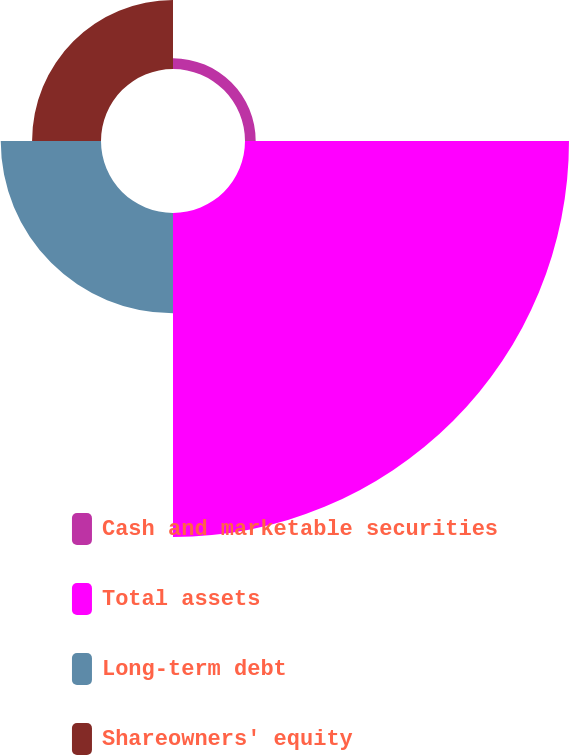Convert chart to OTSL. <chart><loc_0><loc_0><loc_500><loc_500><pie_chart><fcel>Cash and marketable securities<fcel>Total assets<fcel>Long-term debt<fcel>Shareowners' equity<nl><fcel>2.12%<fcel>64.31%<fcel>19.9%<fcel>13.68%<nl></chart> 